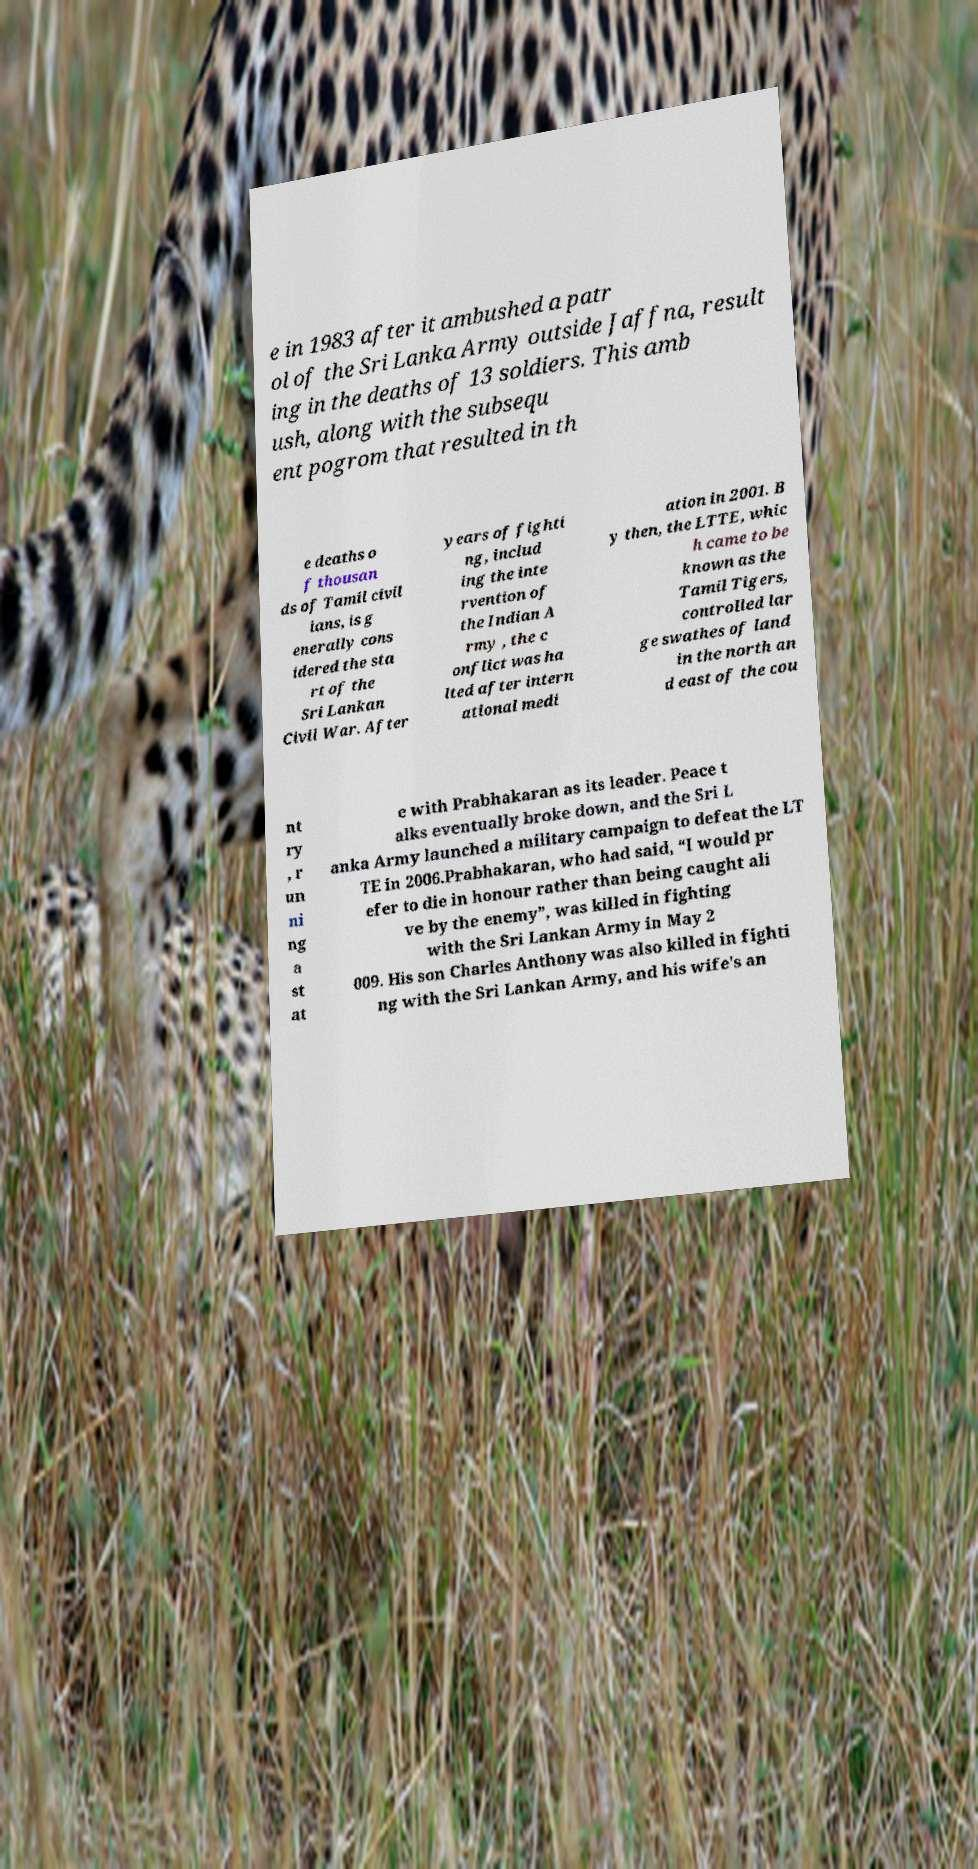What messages or text are displayed in this image? I need them in a readable, typed format. e in 1983 after it ambushed a patr ol of the Sri Lanka Army outside Jaffna, result ing in the deaths of 13 soldiers. This amb ush, along with the subsequ ent pogrom that resulted in th e deaths o f thousan ds of Tamil civil ians, is g enerally cons idered the sta rt of the Sri Lankan Civil War. After years of fighti ng, includ ing the inte rvention of the Indian A rmy , the c onflict was ha lted after intern ational medi ation in 2001. B y then, the LTTE, whic h came to be known as the Tamil Tigers, controlled lar ge swathes of land in the north an d east of the cou nt ry , r un ni ng a st at e with Prabhakaran as its leader. Peace t alks eventually broke down, and the Sri L anka Army launched a military campaign to defeat the LT TE in 2006.Prabhakaran, who had said, “I would pr efer to die in honour rather than being caught ali ve by the enemy”, was killed in fighting with the Sri Lankan Army in May 2 009. His son Charles Anthony was also killed in fighti ng with the Sri Lankan Army, and his wife's an 